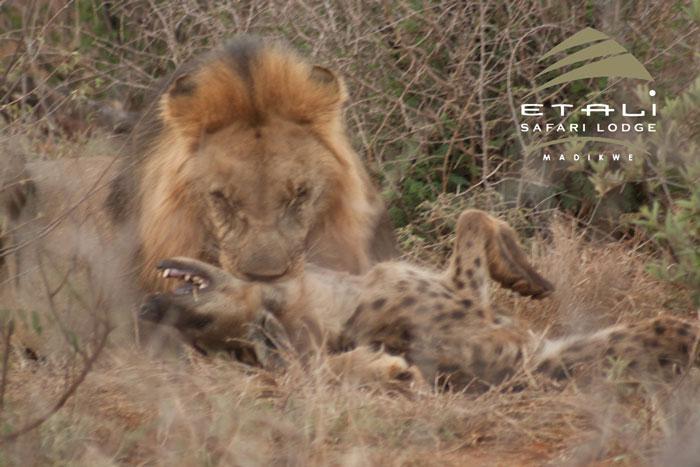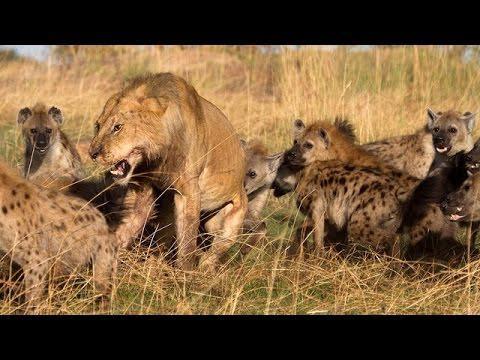The first image is the image on the left, the second image is the image on the right. Analyze the images presented: Is the assertion "The left image contains one lion." valid? Answer yes or no. Yes. The first image is the image on the left, the second image is the image on the right. Given the left and right images, does the statement "In at least one image there is a lion eating a hyena by the neck." hold true? Answer yes or no. Yes. 